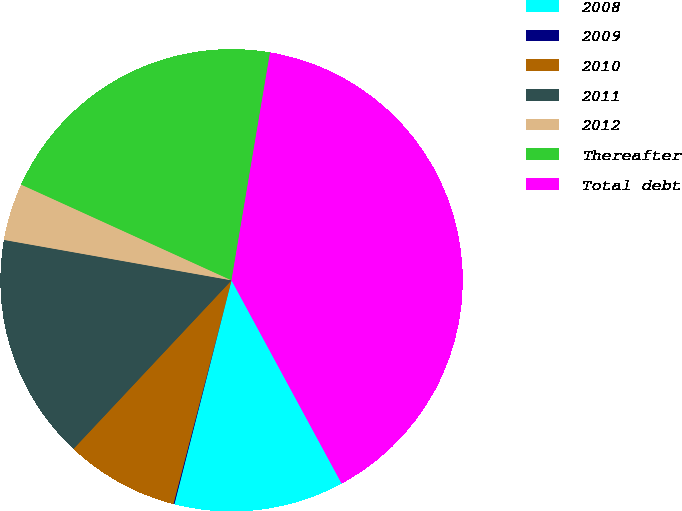Convert chart. <chart><loc_0><loc_0><loc_500><loc_500><pie_chart><fcel>2008<fcel>2009<fcel>2010<fcel>2011<fcel>2012<fcel>Thereafter<fcel>Total debt<nl><fcel>11.88%<fcel>0.07%<fcel>7.94%<fcel>15.81%<fcel>4.0%<fcel>20.87%<fcel>39.43%<nl></chart> 